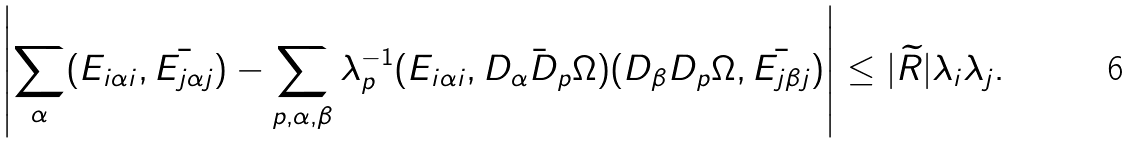<formula> <loc_0><loc_0><loc_500><loc_500>\left | \sum _ { \alpha } ( E _ { i \alpha i } , \bar { E _ { j \alpha j } } ) - \sum _ { p , \alpha , \beta } \lambda _ { p } ^ { - 1 } ( E _ { i \alpha i } , \bar { D _ { \alpha } D _ { p } \Omega } ) ( D _ { \beta } D _ { p } \Omega , \bar { E _ { j \beta j } } ) \right | \leq | \widetilde { R } | \lambda _ { i } \lambda _ { j } .</formula> 